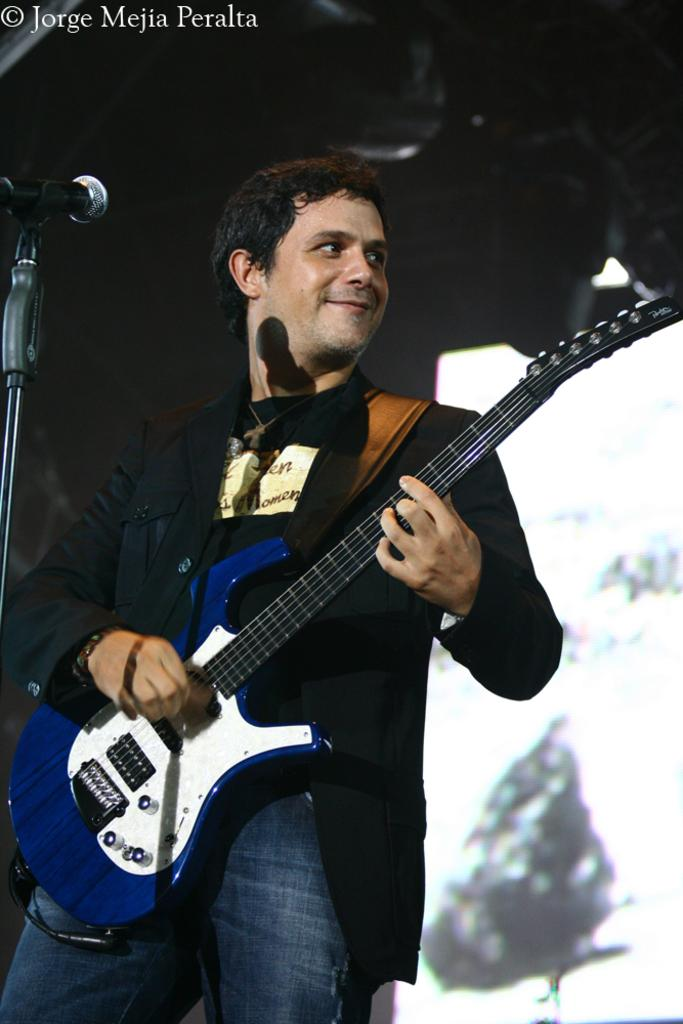What is the main subject of the image? The main subject of the image is a guy standing. What is the guy wearing in the image? The guy is wearing a coat in the image. What object is the guy holding in his hand? The guy is holding a guitar in his hand. What is in front of the guy in the image? There is a microphone in front of the guy. What expression does the guy have in the image? The guy is smiling in the image. What type of oil is being used to play the guitar in the image? There is no oil present in the image, and the guitar is not being played with oil. 